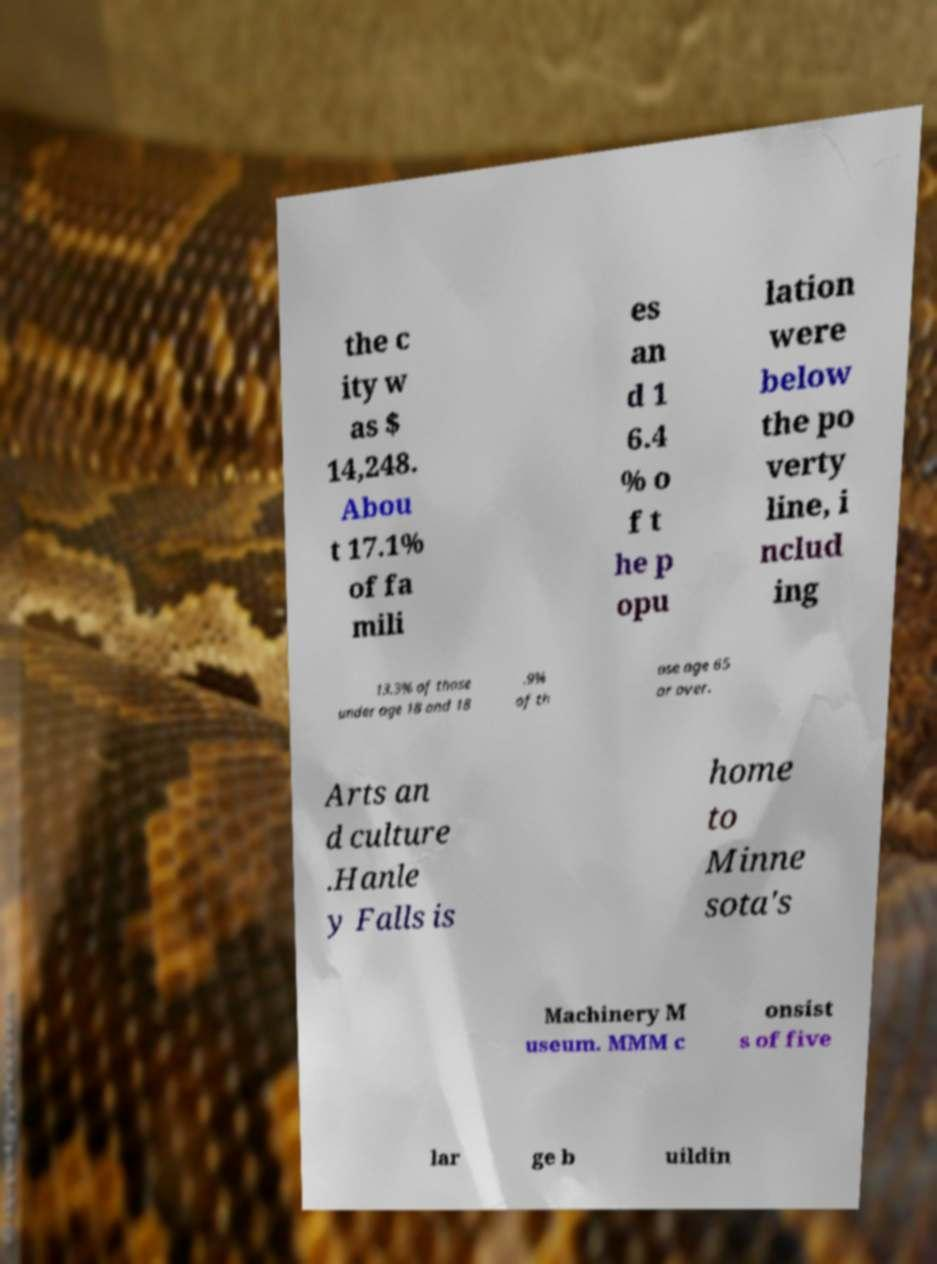What messages or text are displayed in this image? I need them in a readable, typed format. the c ity w as $ 14,248. Abou t 17.1% of fa mili es an d 1 6.4 % o f t he p opu lation were below the po verty line, i nclud ing 13.3% of those under age 18 and 18 .9% of th ose age 65 or over. Arts an d culture .Hanle y Falls is home to Minne sota's Machinery M useum. MMM c onsist s of five lar ge b uildin 